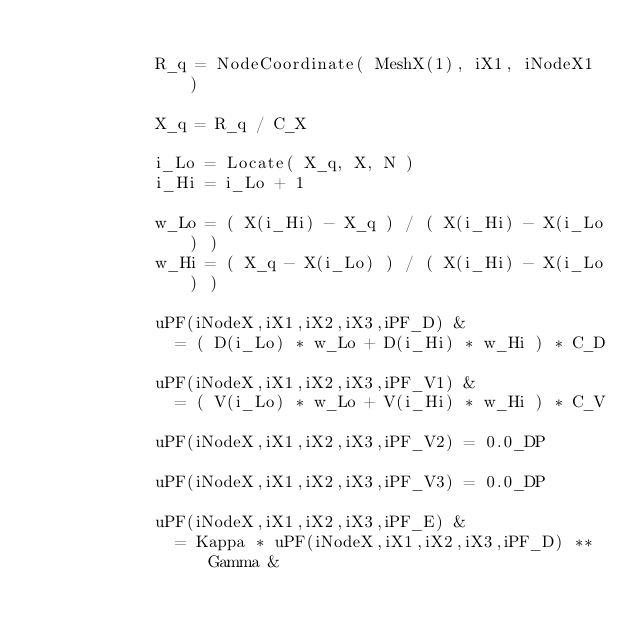Convert code to text. <code><loc_0><loc_0><loc_500><loc_500><_FORTRAN_>
            R_q = NodeCoordinate( MeshX(1), iX1, iNodeX1 )

            X_q = R_q / C_X

            i_Lo = Locate( X_q, X, N )
            i_Hi = i_Lo + 1

            w_Lo = ( X(i_Hi) - X_q ) / ( X(i_Hi) - X(i_Lo) )
            w_Hi = ( X_q - X(i_Lo) ) / ( X(i_Hi) - X(i_Lo) )

            uPF(iNodeX,iX1,iX2,iX3,iPF_D) &
              = ( D(i_Lo) * w_Lo + D(i_Hi) * w_Hi ) * C_D

            uPF(iNodeX,iX1,iX2,iX3,iPF_V1) &
              = ( V(i_Lo) * w_Lo + V(i_Hi) * w_Hi ) * C_V

            uPF(iNodeX,iX1,iX2,iX3,iPF_V2) = 0.0_DP

            uPF(iNodeX,iX1,iX2,iX3,iPF_V3) = 0.0_DP

            uPF(iNodeX,iX1,iX2,iX3,iPF_E) &
              = Kappa * uPF(iNodeX,iX1,iX2,iX3,iPF_D) ** Gamma &</code> 